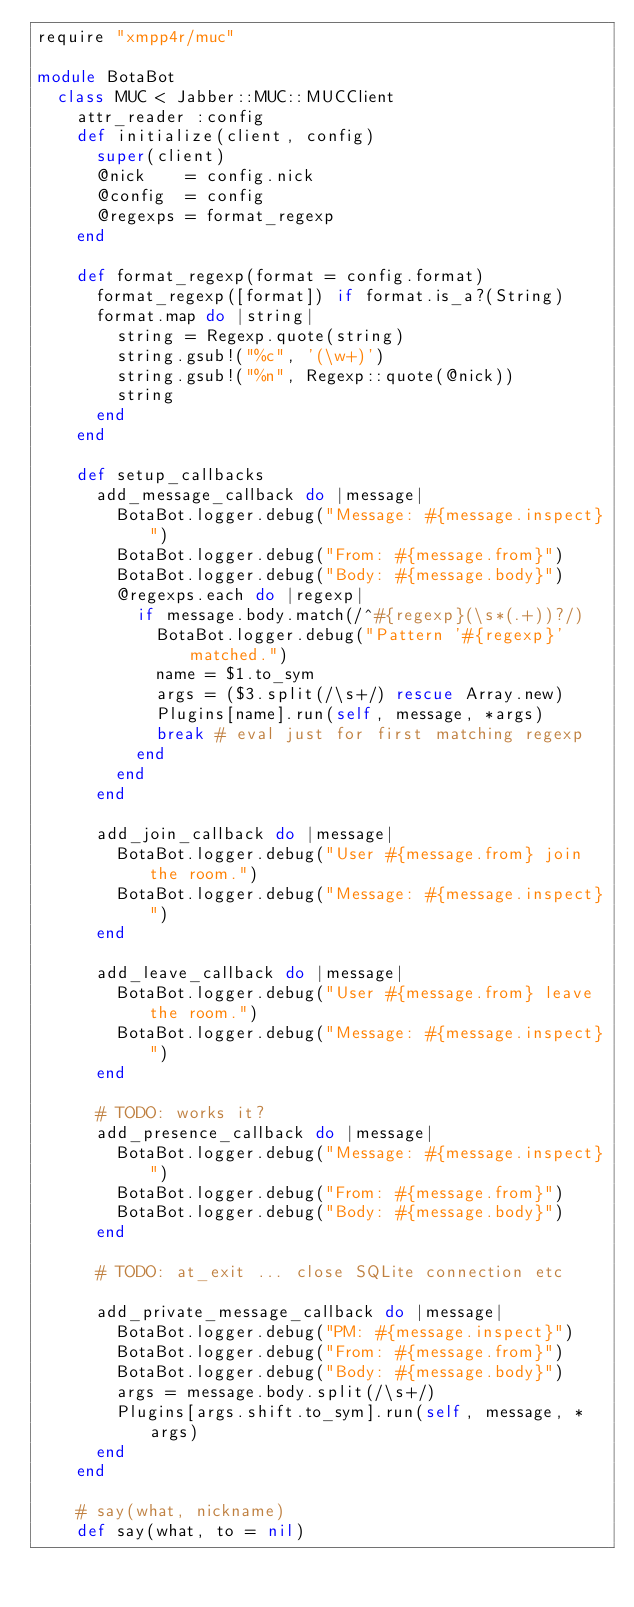<code> <loc_0><loc_0><loc_500><loc_500><_Ruby_>require "xmpp4r/muc"

module BotaBot
  class MUC < Jabber::MUC::MUCClient
    attr_reader :config
    def initialize(client, config)
      super(client)
      @nick    = config.nick
      @config  = config
      @regexps = format_regexp
    end

    def format_regexp(format = config.format)
      format_regexp([format]) if format.is_a?(String)
      format.map do |string|
        string = Regexp.quote(string)
        string.gsub!("%c", '(\w+)')
        string.gsub!("%n", Regexp::quote(@nick))
        string
      end
    end

    def setup_callbacks
      add_message_callback do |message|
        BotaBot.logger.debug("Message: #{message.inspect}")
        BotaBot.logger.debug("From: #{message.from}")
        BotaBot.logger.debug("Body: #{message.body}")
        @regexps.each do |regexp|
          if message.body.match(/^#{regexp}(\s*(.+))?/)
            BotaBot.logger.debug("Pattern '#{regexp}' matched.")
            name = $1.to_sym
            args = ($3.split(/\s+/) rescue Array.new)
            Plugins[name].run(self, message, *args)
            break # eval just for first matching regexp
          end
        end
      end
      
      add_join_callback do |message|
        BotaBot.logger.debug("User #{message.from} join the room.")
        BotaBot.logger.debug("Message: #{message.inspect}")
      end
      
      add_leave_callback do |message|
        BotaBot.logger.debug("User #{message.from} leave the room.")
        BotaBot.logger.debug("Message: #{message.inspect}")
      end
      
      # TODO: works it?
      add_presence_callback do |message|
        BotaBot.logger.debug("Message: #{message.inspect}")
        BotaBot.logger.debug("From: #{message.from}")
        BotaBot.logger.debug("Body: #{message.body}")
      end
      
      # TODO: at_exit ... close SQLite connection etc

      add_private_message_callback do |message|
        BotaBot.logger.debug("PM: #{message.inspect}")
        BotaBot.logger.debug("From: #{message.from}")
        BotaBot.logger.debug("Body: #{message.body}")
        args = message.body.split(/\s+/)
        Plugins[args.shift.to_sym].run(self, message, *args)
      end
    end

    # say(what, nickname)
    def say(what, to = nil)</code> 